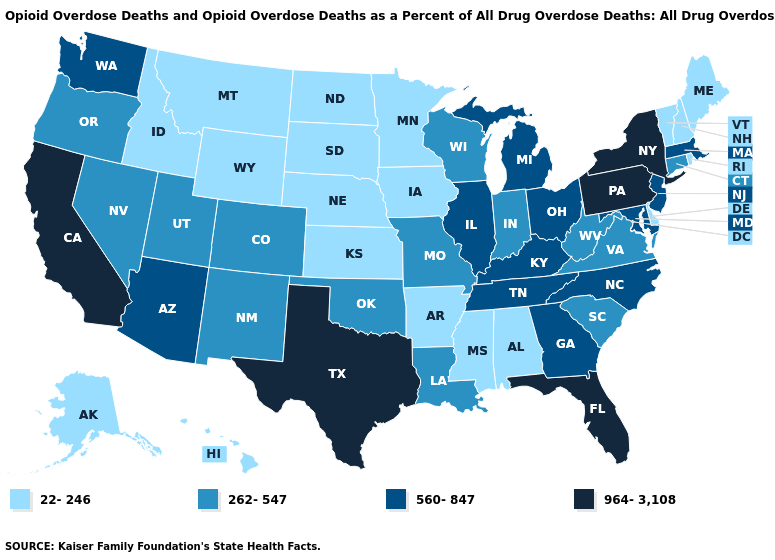What is the value of Montana?
Keep it brief. 22-246. Which states have the highest value in the USA?
Short answer required. California, Florida, New York, Pennsylvania, Texas. What is the lowest value in the Northeast?
Answer briefly. 22-246. Does the first symbol in the legend represent the smallest category?
Keep it brief. Yes. Which states have the highest value in the USA?
Answer briefly. California, Florida, New York, Pennsylvania, Texas. Among the states that border Rhode Island , which have the lowest value?
Give a very brief answer. Connecticut. Does Connecticut have the lowest value in the Northeast?
Keep it brief. No. What is the value of New Hampshire?
Write a very short answer. 22-246. What is the value of California?
Give a very brief answer. 964-3,108. Does North Dakota have the lowest value in the USA?
Give a very brief answer. Yes. What is the value of Connecticut?
Keep it brief. 262-547. Does New Hampshire have the lowest value in the Northeast?
Short answer required. Yes. Does the map have missing data?
Concise answer only. No. Name the states that have a value in the range 560-847?
Keep it brief. Arizona, Georgia, Illinois, Kentucky, Maryland, Massachusetts, Michigan, New Jersey, North Carolina, Ohio, Tennessee, Washington. Does Alaska have the lowest value in the West?
Answer briefly. Yes. 